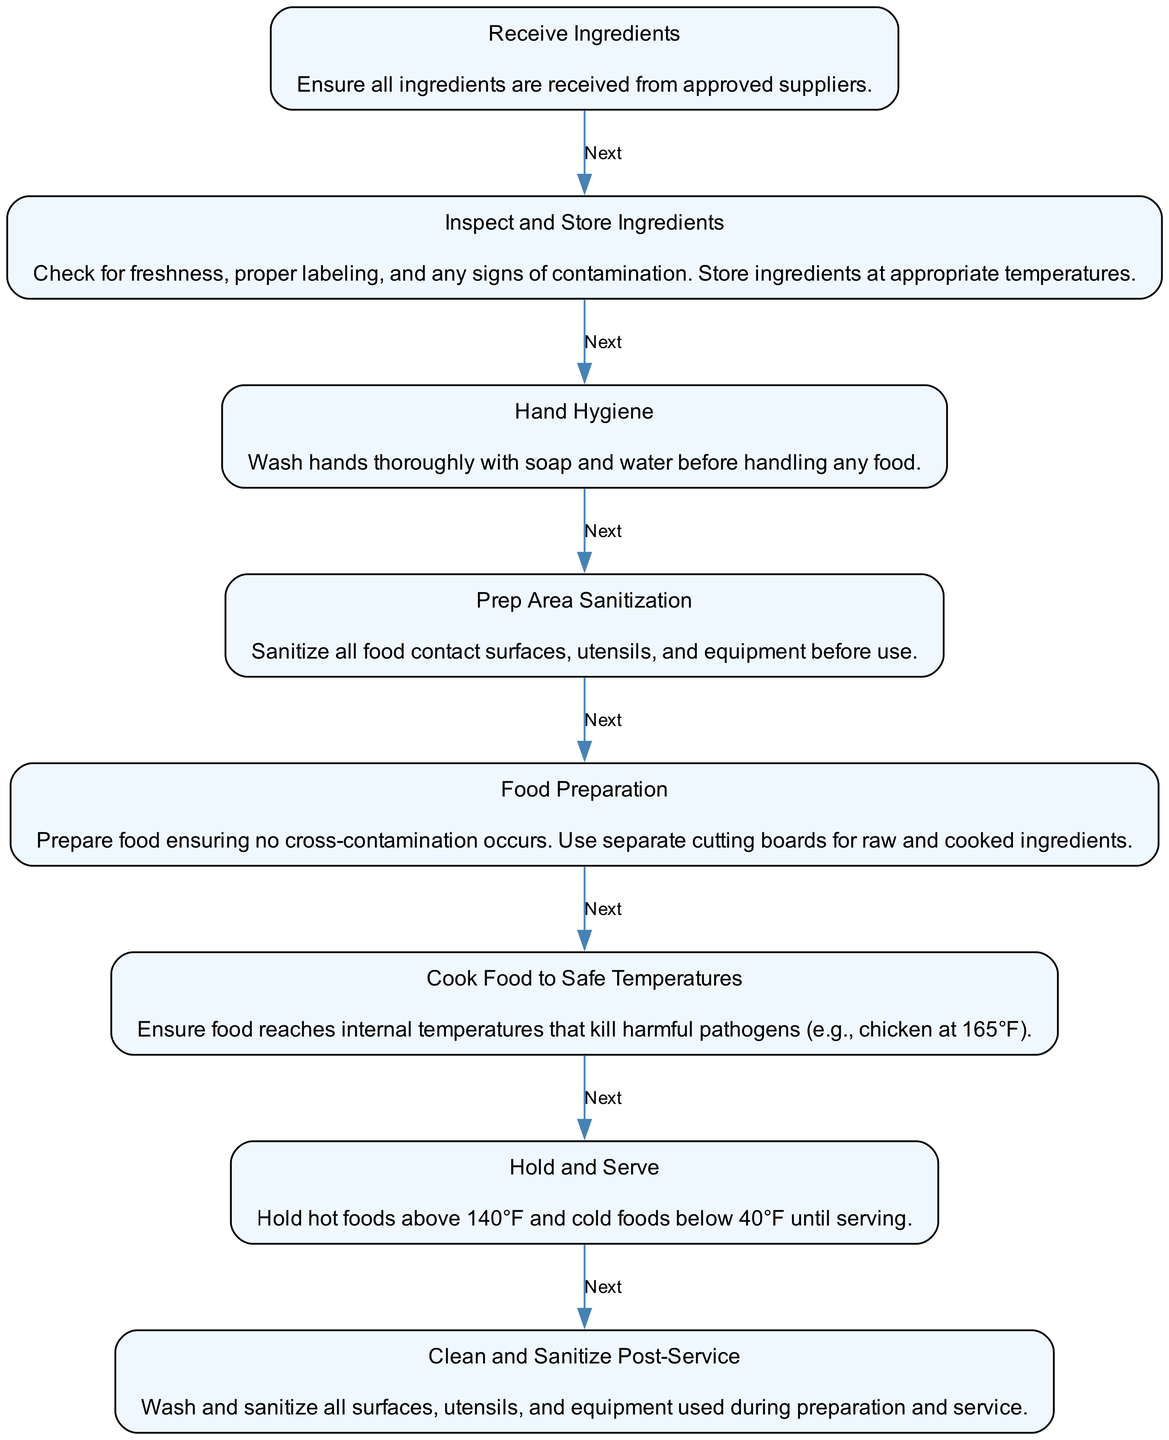What is the last step in the workflow? The last step in the workflow is "Clean and Sanitize Post-Service," which indicates the final action to maintain hygiene after serving food. This can be traced as the final element in the sequence of steps that conclude the entire process.
Answer: Clean and Sanitize Post-Service How many nodes are there in the diagram? The diagram includes eight nodes, which correspond to the steps outlined in the workflow for safe food handling and storage. Each step represents a specific action to be taken, and they are clearly numbered from one to eight.
Answer: Eight What is the description for the 'Food Preparation' step? The description for "Food Preparation" details that food must be prepared while ensuring no cross-contamination occurs and to use separate cutting boards for raw and cooked ingredients. This information can be directly found in the label associated with that specific node.
Answer: Prepare food ensuring no cross-contamination occurs. Use separate cutting boards for raw and cooked ingredients Which steps are involved before cooking food? The steps before cooking food are "Receive Ingredients," "Inspect and Store Ingredients," "Hand Hygiene," "Prep Area Sanitization," and "Food Preparation." These steps can be identified by tracing through the nodes in sequence leading to the cooking step.
Answer: Receive Ingredients, Inspect and Store Ingredients, Hand Hygiene, Prep Area Sanitization, Food Preparation What must be checked during the 'Inspect and Store Ingredients' step? During the "Inspect and Store Ingredients" step, it is crucial to check for freshness, proper labeling, and any signs of contamination, as outlined in the description of that specific node. This is an essential part of maintaining food safety.
Answer: Freshness, proper labeling, signs of contamination What temperatures must hot and cold foods be held at before serving? Hot foods must be held above 140°F and cold foods below 40°F until serving, as stated in the "Hold and Serve" step. These requirements are critical for preventing the growth of harmful pathogens in food.
Answer: Above 140°F, below 40°F What is the purpose of the 'Prep Area Sanitization' step? The purpose of the "Prep Area Sanitization" step is to sanitize all food contact surfaces, utensils, and equipment before use. This step is necessary to prevent any contamination prior to food preparation, which can be found in the specific description of that node.
Answer: Sanitize all food contact surfaces, utensils, and equipment before use 